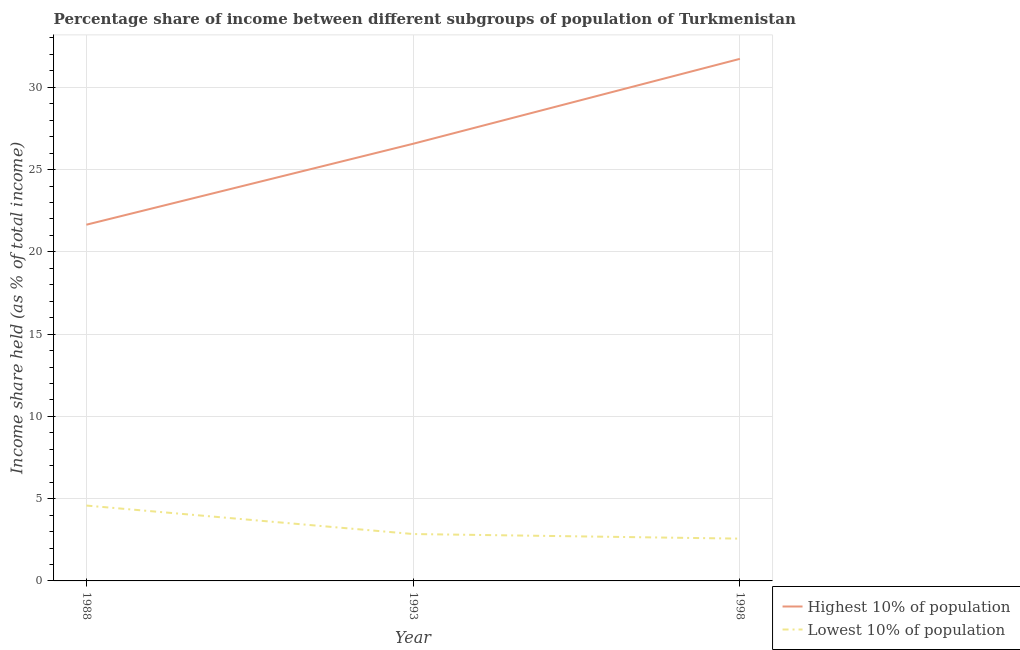How many different coloured lines are there?
Provide a succinct answer. 2. Does the line corresponding to income share held by lowest 10% of the population intersect with the line corresponding to income share held by highest 10% of the population?
Give a very brief answer. No. What is the income share held by highest 10% of the population in 1998?
Keep it short and to the point. 31.73. Across all years, what is the maximum income share held by highest 10% of the population?
Your response must be concise. 31.73. Across all years, what is the minimum income share held by highest 10% of the population?
Your answer should be compact. 21.65. What is the total income share held by highest 10% of the population in the graph?
Provide a succinct answer. 79.95. What is the difference between the income share held by highest 10% of the population in 1988 and that in 1998?
Offer a very short reply. -10.08. What is the difference between the income share held by highest 10% of the population in 1988 and the income share held by lowest 10% of the population in 1993?
Ensure brevity in your answer.  18.8. What is the average income share held by lowest 10% of the population per year?
Keep it short and to the point. 3.33. In the year 1993, what is the difference between the income share held by highest 10% of the population and income share held by lowest 10% of the population?
Offer a very short reply. 23.72. In how many years, is the income share held by highest 10% of the population greater than 19 %?
Make the answer very short. 3. What is the ratio of the income share held by lowest 10% of the population in 1993 to that in 1998?
Ensure brevity in your answer.  1.11. What is the difference between the highest and the second highest income share held by highest 10% of the population?
Offer a terse response. 5.16. What is the difference between the highest and the lowest income share held by lowest 10% of the population?
Give a very brief answer. 2.01. In how many years, is the income share held by highest 10% of the population greater than the average income share held by highest 10% of the population taken over all years?
Offer a terse response. 1. What is the difference between two consecutive major ticks on the Y-axis?
Ensure brevity in your answer.  5. Are the values on the major ticks of Y-axis written in scientific E-notation?
Your response must be concise. No. Does the graph contain any zero values?
Your answer should be compact. No. Does the graph contain grids?
Keep it short and to the point. Yes. Where does the legend appear in the graph?
Your answer should be compact. Bottom right. What is the title of the graph?
Provide a succinct answer. Percentage share of income between different subgroups of population of Turkmenistan. What is the label or title of the X-axis?
Give a very brief answer. Year. What is the label or title of the Y-axis?
Ensure brevity in your answer.  Income share held (as % of total income). What is the Income share held (as % of total income) of Highest 10% of population in 1988?
Provide a succinct answer. 21.65. What is the Income share held (as % of total income) in Lowest 10% of population in 1988?
Offer a very short reply. 4.58. What is the Income share held (as % of total income) in Highest 10% of population in 1993?
Provide a short and direct response. 26.57. What is the Income share held (as % of total income) of Lowest 10% of population in 1993?
Your answer should be very brief. 2.85. What is the Income share held (as % of total income) in Highest 10% of population in 1998?
Your answer should be very brief. 31.73. What is the Income share held (as % of total income) of Lowest 10% of population in 1998?
Keep it short and to the point. 2.57. Across all years, what is the maximum Income share held (as % of total income) of Highest 10% of population?
Provide a short and direct response. 31.73. Across all years, what is the maximum Income share held (as % of total income) of Lowest 10% of population?
Make the answer very short. 4.58. Across all years, what is the minimum Income share held (as % of total income) in Highest 10% of population?
Make the answer very short. 21.65. Across all years, what is the minimum Income share held (as % of total income) of Lowest 10% of population?
Provide a succinct answer. 2.57. What is the total Income share held (as % of total income) in Highest 10% of population in the graph?
Provide a short and direct response. 79.95. What is the total Income share held (as % of total income) of Lowest 10% of population in the graph?
Ensure brevity in your answer.  10. What is the difference between the Income share held (as % of total income) of Highest 10% of population in 1988 and that in 1993?
Provide a short and direct response. -4.92. What is the difference between the Income share held (as % of total income) in Lowest 10% of population in 1988 and that in 1993?
Keep it short and to the point. 1.73. What is the difference between the Income share held (as % of total income) of Highest 10% of population in 1988 and that in 1998?
Ensure brevity in your answer.  -10.08. What is the difference between the Income share held (as % of total income) of Lowest 10% of population in 1988 and that in 1998?
Offer a very short reply. 2.01. What is the difference between the Income share held (as % of total income) of Highest 10% of population in 1993 and that in 1998?
Offer a terse response. -5.16. What is the difference between the Income share held (as % of total income) in Lowest 10% of population in 1993 and that in 1998?
Your answer should be very brief. 0.28. What is the difference between the Income share held (as % of total income) of Highest 10% of population in 1988 and the Income share held (as % of total income) of Lowest 10% of population in 1998?
Your answer should be very brief. 19.08. What is the average Income share held (as % of total income) in Highest 10% of population per year?
Keep it short and to the point. 26.65. What is the average Income share held (as % of total income) in Lowest 10% of population per year?
Ensure brevity in your answer.  3.33. In the year 1988, what is the difference between the Income share held (as % of total income) of Highest 10% of population and Income share held (as % of total income) of Lowest 10% of population?
Your answer should be compact. 17.07. In the year 1993, what is the difference between the Income share held (as % of total income) of Highest 10% of population and Income share held (as % of total income) of Lowest 10% of population?
Your answer should be very brief. 23.72. In the year 1998, what is the difference between the Income share held (as % of total income) of Highest 10% of population and Income share held (as % of total income) of Lowest 10% of population?
Offer a terse response. 29.16. What is the ratio of the Income share held (as % of total income) of Highest 10% of population in 1988 to that in 1993?
Provide a succinct answer. 0.81. What is the ratio of the Income share held (as % of total income) in Lowest 10% of population in 1988 to that in 1993?
Your answer should be compact. 1.61. What is the ratio of the Income share held (as % of total income) of Highest 10% of population in 1988 to that in 1998?
Your answer should be very brief. 0.68. What is the ratio of the Income share held (as % of total income) in Lowest 10% of population in 1988 to that in 1998?
Provide a succinct answer. 1.78. What is the ratio of the Income share held (as % of total income) in Highest 10% of population in 1993 to that in 1998?
Offer a very short reply. 0.84. What is the ratio of the Income share held (as % of total income) in Lowest 10% of population in 1993 to that in 1998?
Your response must be concise. 1.11. What is the difference between the highest and the second highest Income share held (as % of total income) of Highest 10% of population?
Offer a very short reply. 5.16. What is the difference between the highest and the second highest Income share held (as % of total income) of Lowest 10% of population?
Give a very brief answer. 1.73. What is the difference between the highest and the lowest Income share held (as % of total income) in Highest 10% of population?
Your answer should be very brief. 10.08. What is the difference between the highest and the lowest Income share held (as % of total income) in Lowest 10% of population?
Make the answer very short. 2.01. 